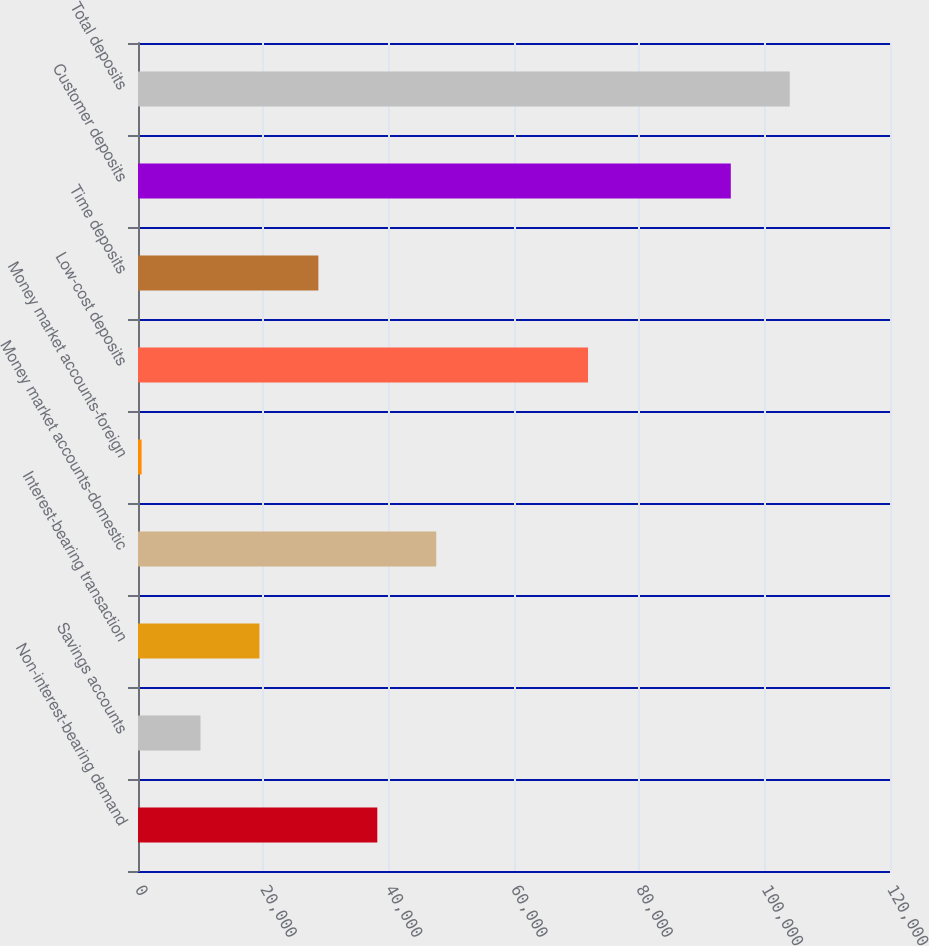<chart> <loc_0><loc_0><loc_500><loc_500><bar_chart><fcel>Non-interest-bearing demand<fcel>Savings accounts<fcel>Interest-bearing transaction<fcel>Money market accounts-domestic<fcel>Money market accounts-foreign<fcel>Low-cost deposits<fcel>Time deposits<fcel>Customer deposits<fcel>Total deposits<nl><fcel>38187<fcel>9973.5<fcel>19378<fcel>47591.5<fcel>569<fcel>71813<fcel>28782.5<fcel>94597<fcel>104002<nl></chart> 